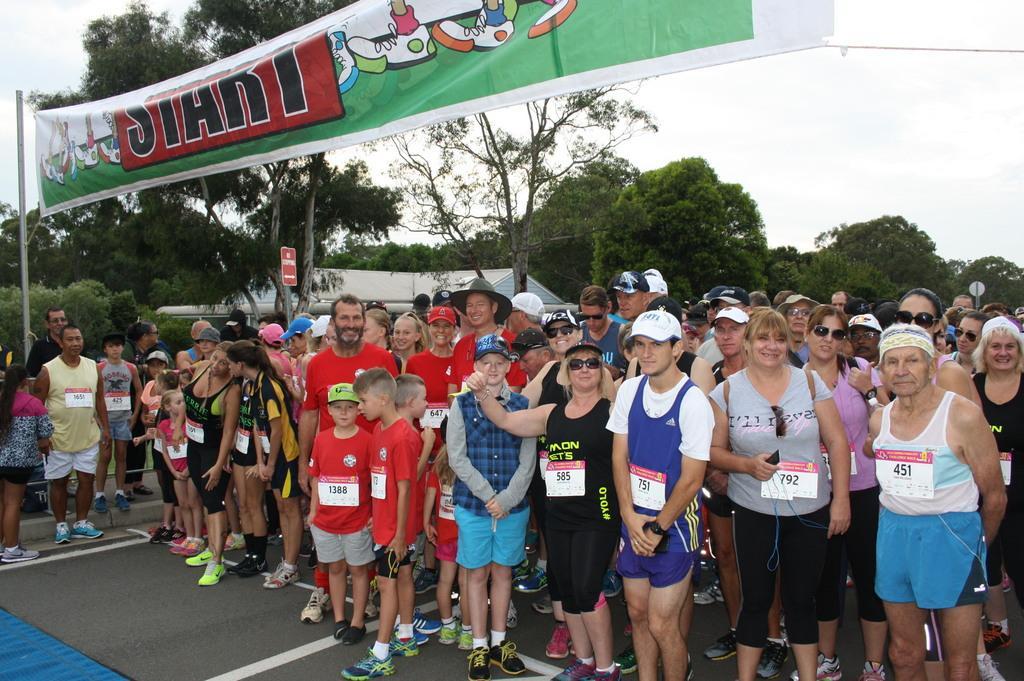Describe this image in one or two sentences. In this picture we can see some people standing in the front, in the background there are some trees, on the left side there is a pole, we can see a banner and the sky at the top of the picture, some of these people wore caps. 